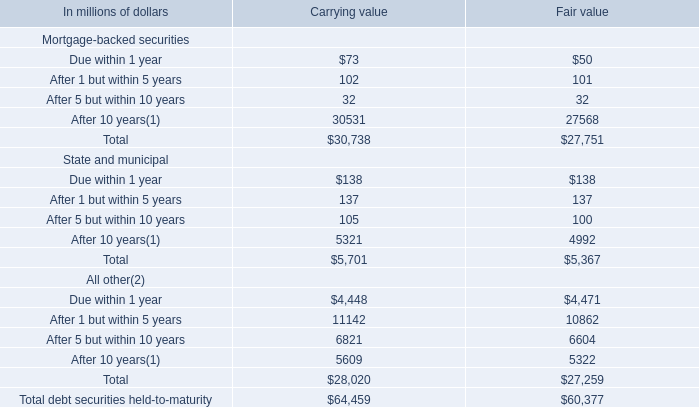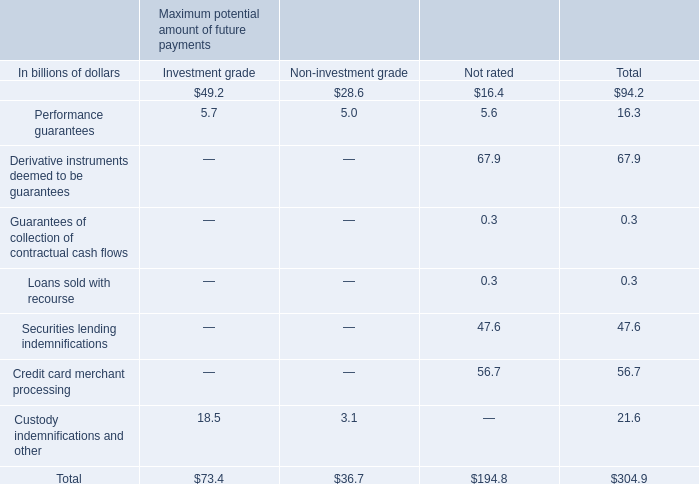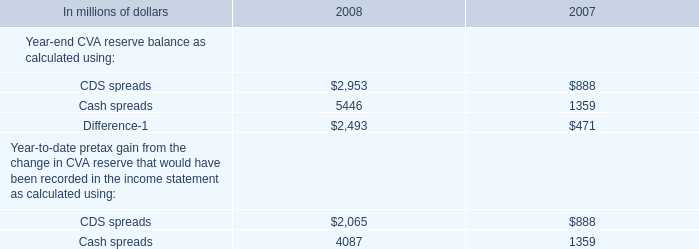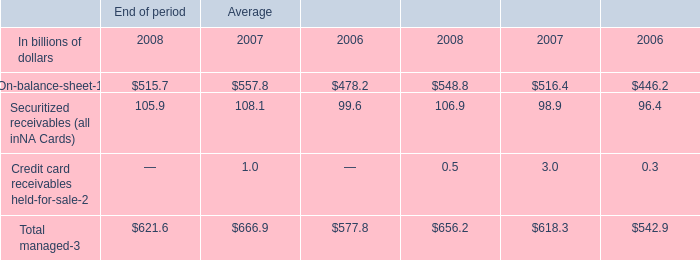what's the total amount of CDS spreads of 2008, and After 10 years All other of Fair value ? 
Computations: (2953.0 + 5322.0)
Answer: 8275.0. 